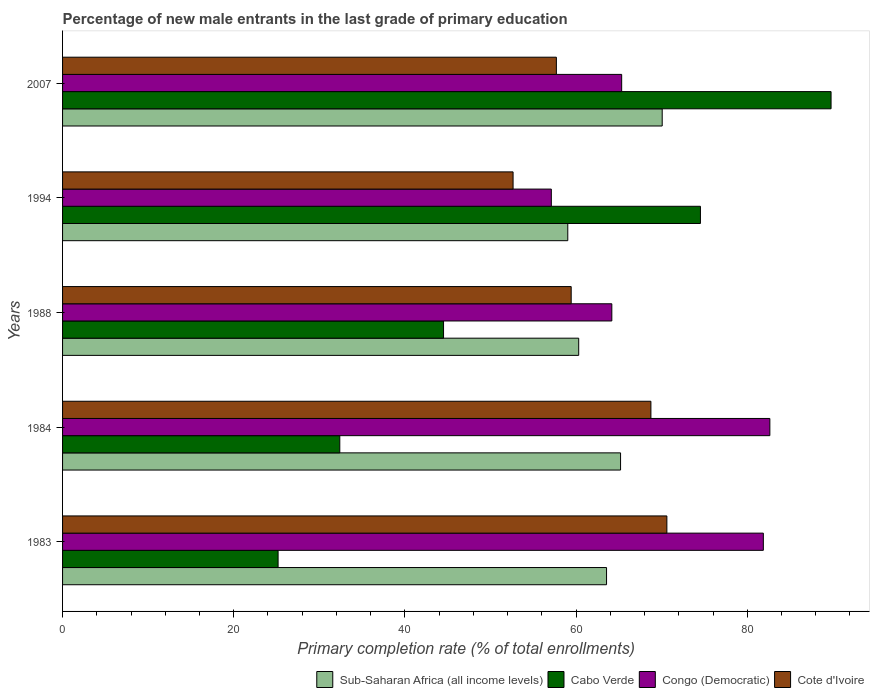How many different coloured bars are there?
Offer a terse response. 4. Are the number of bars on each tick of the Y-axis equal?
Ensure brevity in your answer.  Yes. How many bars are there on the 5th tick from the bottom?
Your response must be concise. 4. In how many cases, is the number of bars for a given year not equal to the number of legend labels?
Your answer should be compact. 0. What is the percentage of new male entrants in Cote d'Ivoire in 2007?
Make the answer very short. 57.7. Across all years, what is the maximum percentage of new male entrants in Sub-Saharan Africa (all income levels)?
Keep it short and to the point. 70.06. Across all years, what is the minimum percentage of new male entrants in Sub-Saharan Africa (all income levels)?
Provide a short and direct response. 59.03. In which year was the percentage of new male entrants in Congo (Democratic) maximum?
Ensure brevity in your answer.  1984. In which year was the percentage of new male entrants in Cote d'Ivoire minimum?
Give a very brief answer. 1994. What is the total percentage of new male entrants in Congo (Democratic) in the graph?
Offer a very short reply. 351.14. What is the difference between the percentage of new male entrants in Cabo Verde in 1988 and that in 2007?
Ensure brevity in your answer.  -45.28. What is the difference between the percentage of new male entrants in Sub-Saharan Africa (all income levels) in 1983 and the percentage of new male entrants in Cote d'Ivoire in 2007?
Your response must be concise. 5.86. What is the average percentage of new male entrants in Cote d'Ivoire per year?
Offer a terse response. 61.82. In the year 1994, what is the difference between the percentage of new male entrants in Cabo Verde and percentage of new male entrants in Sub-Saharan Africa (all income levels)?
Your answer should be compact. 15.5. In how many years, is the percentage of new male entrants in Cabo Verde greater than 24 %?
Offer a very short reply. 5. What is the ratio of the percentage of new male entrants in Sub-Saharan Africa (all income levels) in 1983 to that in 1994?
Your response must be concise. 1.08. What is the difference between the highest and the second highest percentage of new male entrants in Cote d'Ivoire?
Provide a succinct answer. 1.87. What is the difference between the highest and the lowest percentage of new male entrants in Sub-Saharan Africa (all income levels)?
Give a very brief answer. 11.03. Is it the case that in every year, the sum of the percentage of new male entrants in Sub-Saharan Africa (all income levels) and percentage of new male entrants in Cabo Verde is greater than the sum of percentage of new male entrants in Congo (Democratic) and percentage of new male entrants in Cote d'Ivoire?
Your answer should be compact. No. What does the 3rd bar from the top in 1984 represents?
Ensure brevity in your answer.  Cabo Verde. What does the 4th bar from the bottom in 1983 represents?
Provide a succinct answer. Cote d'Ivoire. Is it the case that in every year, the sum of the percentage of new male entrants in Cote d'Ivoire and percentage of new male entrants in Sub-Saharan Africa (all income levels) is greater than the percentage of new male entrants in Cabo Verde?
Provide a succinct answer. Yes. How many bars are there?
Provide a succinct answer. 20. Are all the bars in the graph horizontal?
Ensure brevity in your answer.  Yes. What is the difference between two consecutive major ticks on the X-axis?
Offer a terse response. 20. Are the values on the major ticks of X-axis written in scientific E-notation?
Your answer should be compact. No. Does the graph contain any zero values?
Your answer should be very brief. No. How are the legend labels stacked?
Your answer should be compact. Horizontal. What is the title of the graph?
Offer a very short reply. Percentage of new male entrants in the last grade of primary education. What is the label or title of the X-axis?
Provide a short and direct response. Primary completion rate (% of total enrollments). What is the Primary completion rate (% of total enrollments) in Sub-Saharan Africa (all income levels) in 1983?
Your answer should be very brief. 63.56. What is the Primary completion rate (% of total enrollments) in Cabo Verde in 1983?
Provide a short and direct response. 25.18. What is the Primary completion rate (% of total enrollments) of Congo (Democratic) in 1983?
Keep it short and to the point. 81.88. What is the Primary completion rate (% of total enrollments) of Cote d'Ivoire in 1983?
Keep it short and to the point. 70.61. What is the Primary completion rate (% of total enrollments) of Sub-Saharan Africa (all income levels) in 1984?
Keep it short and to the point. 65.2. What is the Primary completion rate (% of total enrollments) of Cabo Verde in 1984?
Ensure brevity in your answer.  32.39. What is the Primary completion rate (% of total enrollments) of Congo (Democratic) in 1984?
Ensure brevity in your answer.  82.64. What is the Primary completion rate (% of total enrollments) in Cote d'Ivoire in 1984?
Make the answer very short. 68.74. What is the Primary completion rate (% of total enrollments) of Sub-Saharan Africa (all income levels) in 1988?
Your response must be concise. 60.31. What is the Primary completion rate (% of total enrollments) of Cabo Verde in 1988?
Keep it short and to the point. 44.52. What is the Primary completion rate (% of total enrollments) in Congo (Democratic) in 1988?
Make the answer very short. 64.18. What is the Primary completion rate (% of total enrollments) in Cote d'Ivoire in 1988?
Your answer should be very brief. 59.43. What is the Primary completion rate (% of total enrollments) in Sub-Saharan Africa (all income levels) in 1994?
Your response must be concise. 59.03. What is the Primary completion rate (% of total enrollments) of Cabo Verde in 1994?
Provide a succinct answer. 74.53. What is the Primary completion rate (% of total enrollments) in Congo (Democratic) in 1994?
Make the answer very short. 57.11. What is the Primary completion rate (% of total enrollments) of Cote d'Ivoire in 1994?
Your answer should be very brief. 52.64. What is the Primary completion rate (% of total enrollments) of Sub-Saharan Africa (all income levels) in 2007?
Your answer should be compact. 70.06. What is the Primary completion rate (% of total enrollments) in Cabo Verde in 2007?
Provide a succinct answer. 89.8. What is the Primary completion rate (% of total enrollments) in Congo (Democratic) in 2007?
Make the answer very short. 65.33. What is the Primary completion rate (% of total enrollments) of Cote d'Ivoire in 2007?
Provide a short and direct response. 57.7. Across all years, what is the maximum Primary completion rate (% of total enrollments) of Sub-Saharan Africa (all income levels)?
Give a very brief answer. 70.06. Across all years, what is the maximum Primary completion rate (% of total enrollments) in Cabo Verde?
Your answer should be compact. 89.8. Across all years, what is the maximum Primary completion rate (% of total enrollments) of Congo (Democratic)?
Provide a short and direct response. 82.64. Across all years, what is the maximum Primary completion rate (% of total enrollments) of Cote d'Ivoire?
Ensure brevity in your answer.  70.61. Across all years, what is the minimum Primary completion rate (% of total enrollments) of Sub-Saharan Africa (all income levels)?
Ensure brevity in your answer.  59.03. Across all years, what is the minimum Primary completion rate (% of total enrollments) in Cabo Verde?
Keep it short and to the point. 25.18. Across all years, what is the minimum Primary completion rate (% of total enrollments) of Congo (Democratic)?
Your answer should be compact. 57.11. Across all years, what is the minimum Primary completion rate (% of total enrollments) in Cote d'Ivoire?
Your answer should be compact. 52.64. What is the total Primary completion rate (% of total enrollments) of Sub-Saharan Africa (all income levels) in the graph?
Offer a terse response. 318.17. What is the total Primary completion rate (% of total enrollments) in Cabo Verde in the graph?
Provide a short and direct response. 266.42. What is the total Primary completion rate (% of total enrollments) of Congo (Democratic) in the graph?
Make the answer very short. 351.14. What is the total Primary completion rate (% of total enrollments) of Cote d'Ivoire in the graph?
Your answer should be compact. 309.12. What is the difference between the Primary completion rate (% of total enrollments) of Sub-Saharan Africa (all income levels) in 1983 and that in 1984?
Provide a succinct answer. -1.64. What is the difference between the Primary completion rate (% of total enrollments) of Cabo Verde in 1983 and that in 1984?
Your answer should be very brief. -7.21. What is the difference between the Primary completion rate (% of total enrollments) in Congo (Democratic) in 1983 and that in 1984?
Provide a succinct answer. -0.76. What is the difference between the Primary completion rate (% of total enrollments) of Cote d'Ivoire in 1983 and that in 1984?
Give a very brief answer. 1.87. What is the difference between the Primary completion rate (% of total enrollments) of Sub-Saharan Africa (all income levels) in 1983 and that in 1988?
Provide a succinct answer. 3.25. What is the difference between the Primary completion rate (% of total enrollments) of Cabo Verde in 1983 and that in 1988?
Ensure brevity in your answer.  -19.33. What is the difference between the Primary completion rate (% of total enrollments) in Congo (Democratic) in 1983 and that in 1988?
Offer a very short reply. 17.7. What is the difference between the Primary completion rate (% of total enrollments) in Cote d'Ivoire in 1983 and that in 1988?
Your answer should be very brief. 11.18. What is the difference between the Primary completion rate (% of total enrollments) in Sub-Saharan Africa (all income levels) in 1983 and that in 1994?
Make the answer very short. 4.53. What is the difference between the Primary completion rate (% of total enrollments) in Cabo Verde in 1983 and that in 1994?
Your answer should be compact. -49.35. What is the difference between the Primary completion rate (% of total enrollments) of Congo (Democratic) in 1983 and that in 1994?
Your answer should be compact. 24.77. What is the difference between the Primary completion rate (% of total enrollments) in Cote d'Ivoire in 1983 and that in 1994?
Provide a short and direct response. 17.97. What is the difference between the Primary completion rate (% of total enrollments) in Sub-Saharan Africa (all income levels) in 1983 and that in 2007?
Offer a terse response. -6.5. What is the difference between the Primary completion rate (% of total enrollments) of Cabo Verde in 1983 and that in 2007?
Give a very brief answer. -64.61. What is the difference between the Primary completion rate (% of total enrollments) in Congo (Democratic) in 1983 and that in 2007?
Provide a short and direct response. 16.55. What is the difference between the Primary completion rate (% of total enrollments) of Cote d'Ivoire in 1983 and that in 2007?
Your answer should be compact. 12.91. What is the difference between the Primary completion rate (% of total enrollments) of Sub-Saharan Africa (all income levels) in 1984 and that in 1988?
Provide a short and direct response. 4.89. What is the difference between the Primary completion rate (% of total enrollments) of Cabo Verde in 1984 and that in 1988?
Make the answer very short. -12.12. What is the difference between the Primary completion rate (% of total enrollments) in Congo (Democratic) in 1984 and that in 1988?
Your response must be concise. 18.46. What is the difference between the Primary completion rate (% of total enrollments) in Cote d'Ivoire in 1984 and that in 1988?
Provide a succinct answer. 9.31. What is the difference between the Primary completion rate (% of total enrollments) in Sub-Saharan Africa (all income levels) in 1984 and that in 1994?
Your answer should be compact. 6.17. What is the difference between the Primary completion rate (% of total enrollments) in Cabo Verde in 1984 and that in 1994?
Make the answer very short. -42.14. What is the difference between the Primary completion rate (% of total enrollments) of Congo (Democratic) in 1984 and that in 1994?
Offer a very short reply. 25.53. What is the difference between the Primary completion rate (% of total enrollments) in Cote d'Ivoire in 1984 and that in 1994?
Your answer should be very brief. 16.1. What is the difference between the Primary completion rate (% of total enrollments) in Sub-Saharan Africa (all income levels) in 1984 and that in 2007?
Your answer should be very brief. -4.86. What is the difference between the Primary completion rate (% of total enrollments) in Cabo Verde in 1984 and that in 2007?
Offer a very short reply. -57.4. What is the difference between the Primary completion rate (% of total enrollments) of Congo (Democratic) in 1984 and that in 2007?
Give a very brief answer. 17.31. What is the difference between the Primary completion rate (% of total enrollments) of Cote d'Ivoire in 1984 and that in 2007?
Offer a very short reply. 11.05. What is the difference between the Primary completion rate (% of total enrollments) of Sub-Saharan Africa (all income levels) in 1988 and that in 1994?
Your answer should be compact. 1.28. What is the difference between the Primary completion rate (% of total enrollments) in Cabo Verde in 1988 and that in 1994?
Keep it short and to the point. -30.02. What is the difference between the Primary completion rate (% of total enrollments) of Congo (Democratic) in 1988 and that in 1994?
Your answer should be very brief. 7.07. What is the difference between the Primary completion rate (% of total enrollments) in Cote d'Ivoire in 1988 and that in 1994?
Your response must be concise. 6.79. What is the difference between the Primary completion rate (% of total enrollments) of Sub-Saharan Africa (all income levels) in 1988 and that in 2007?
Give a very brief answer. -9.76. What is the difference between the Primary completion rate (% of total enrollments) in Cabo Verde in 1988 and that in 2007?
Provide a short and direct response. -45.28. What is the difference between the Primary completion rate (% of total enrollments) in Congo (Democratic) in 1988 and that in 2007?
Make the answer very short. -1.15. What is the difference between the Primary completion rate (% of total enrollments) in Cote d'Ivoire in 1988 and that in 2007?
Offer a terse response. 1.73. What is the difference between the Primary completion rate (% of total enrollments) in Sub-Saharan Africa (all income levels) in 1994 and that in 2007?
Your answer should be very brief. -11.03. What is the difference between the Primary completion rate (% of total enrollments) in Cabo Verde in 1994 and that in 2007?
Make the answer very short. -15.26. What is the difference between the Primary completion rate (% of total enrollments) in Congo (Democratic) in 1994 and that in 2007?
Your response must be concise. -8.22. What is the difference between the Primary completion rate (% of total enrollments) of Cote d'Ivoire in 1994 and that in 2007?
Make the answer very short. -5.06. What is the difference between the Primary completion rate (% of total enrollments) of Sub-Saharan Africa (all income levels) in 1983 and the Primary completion rate (% of total enrollments) of Cabo Verde in 1984?
Offer a very short reply. 31.17. What is the difference between the Primary completion rate (% of total enrollments) of Sub-Saharan Africa (all income levels) in 1983 and the Primary completion rate (% of total enrollments) of Congo (Democratic) in 1984?
Ensure brevity in your answer.  -19.08. What is the difference between the Primary completion rate (% of total enrollments) in Sub-Saharan Africa (all income levels) in 1983 and the Primary completion rate (% of total enrollments) in Cote d'Ivoire in 1984?
Ensure brevity in your answer.  -5.18. What is the difference between the Primary completion rate (% of total enrollments) of Cabo Verde in 1983 and the Primary completion rate (% of total enrollments) of Congo (Democratic) in 1984?
Give a very brief answer. -57.46. What is the difference between the Primary completion rate (% of total enrollments) in Cabo Verde in 1983 and the Primary completion rate (% of total enrollments) in Cote d'Ivoire in 1984?
Your answer should be very brief. -43.56. What is the difference between the Primary completion rate (% of total enrollments) of Congo (Democratic) in 1983 and the Primary completion rate (% of total enrollments) of Cote d'Ivoire in 1984?
Ensure brevity in your answer.  13.14. What is the difference between the Primary completion rate (% of total enrollments) of Sub-Saharan Africa (all income levels) in 1983 and the Primary completion rate (% of total enrollments) of Cabo Verde in 1988?
Your answer should be very brief. 19.05. What is the difference between the Primary completion rate (% of total enrollments) in Sub-Saharan Africa (all income levels) in 1983 and the Primary completion rate (% of total enrollments) in Congo (Democratic) in 1988?
Give a very brief answer. -0.62. What is the difference between the Primary completion rate (% of total enrollments) of Sub-Saharan Africa (all income levels) in 1983 and the Primary completion rate (% of total enrollments) of Cote d'Ivoire in 1988?
Your answer should be very brief. 4.13. What is the difference between the Primary completion rate (% of total enrollments) in Cabo Verde in 1983 and the Primary completion rate (% of total enrollments) in Congo (Democratic) in 1988?
Provide a succinct answer. -39. What is the difference between the Primary completion rate (% of total enrollments) of Cabo Verde in 1983 and the Primary completion rate (% of total enrollments) of Cote d'Ivoire in 1988?
Your answer should be compact. -34.25. What is the difference between the Primary completion rate (% of total enrollments) of Congo (Democratic) in 1983 and the Primary completion rate (% of total enrollments) of Cote d'Ivoire in 1988?
Ensure brevity in your answer.  22.45. What is the difference between the Primary completion rate (% of total enrollments) in Sub-Saharan Africa (all income levels) in 1983 and the Primary completion rate (% of total enrollments) in Cabo Verde in 1994?
Provide a succinct answer. -10.97. What is the difference between the Primary completion rate (% of total enrollments) in Sub-Saharan Africa (all income levels) in 1983 and the Primary completion rate (% of total enrollments) in Congo (Democratic) in 1994?
Ensure brevity in your answer.  6.45. What is the difference between the Primary completion rate (% of total enrollments) of Sub-Saharan Africa (all income levels) in 1983 and the Primary completion rate (% of total enrollments) of Cote d'Ivoire in 1994?
Offer a terse response. 10.92. What is the difference between the Primary completion rate (% of total enrollments) in Cabo Verde in 1983 and the Primary completion rate (% of total enrollments) in Congo (Democratic) in 1994?
Provide a succinct answer. -31.93. What is the difference between the Primary completion rate (% of total enrollments) of Cabo Verde in 1983 and the Primary completion rate (% of total enrollments) of Cote d'Ivoire in 1994?
Give a very brief answer. -27.46. What is the difference between the Primary completion rate (% of total enrollments) of Congo (Democratic) in 1983 and the Primary completion rate (% of total enrollments) of Cote d'Ivoire in 1994?
Your response must be concise. 29.24. What is the difference between the Primary completion rate (% of total enrollments) in Sub-Saharan Africa (all income levels) in 1983 and the Primary completion rate (% of total enrollments) in Cabo Verde in 2007?
Your answer should be compact. -26.23. What is the difference between the Primary completion rate (% of total enrollments) of Sub-Saharan Africa (all income levels) in 1983 and the Primary completion rate (% of total enrollments) of Congo (Democratic) in 2007?
Provide a short and direct response. -1.77. What is the difference between the Primary completion rate (% of total enrollments) of Sub-Saharan Africa (all income levels) in 1983 and the Primary completion rate (% of total enrollments) of Cote d'Ivoire in 2007?
Make the answer very short. 5.86. What is the difference between the Primary completion rate (% of total enrollments) in Cabo Verde in 1983 and the Primary completion rate (% of total enrollments) in Congo (Democratic) in 2007?
Give a very brief answer. -40.15. What is the difference between the Primary completion rate (% of total enrollments) in Cabo Verde in 1983 and the Primary completion rate (% of total enrollments) in Cote d'Ivoire in 2007?
Ensure brevity in your answer.  -32.52. What is the difference between the Primary completion rate (% of total enrollments) in Congo (Democratic) in 1983 and the Primary completion rate (% of total enrollments) in Cote d'Ivoire in 2007?
Your answer should be compact. 24.18. What is the difference between the Primary completion rate (% of total enrollments) in Sub-Saharan Africa (all income levels) in 1984 and the Primary completion rate (% of total enrollments) in Cabo Verde in 1988?
Your answer should be compact. 20.68. What is the difference between the Primary completion rate (% of total enrollments) of Sub-Saharan Africa (all income levels) in 1984 and the Primary completion rate (% of total enrollments) of Congo (Democratic) in 1988?
Keep it short and to the point. 1.02. What is the difference between the Primary completion rate (% of total enrollments) of Sub-Saharan Africa (all income levels) in 1984 and the Primary completion rate (% of total enrollments) of Cote d'Ivoire in 1988?
Your response must be concise. 5.77. What is the difference between the Primary completion rate (% of total enrollments) in Cabo Verde in 1984 and the Primary completion rate (% of total enrollments) in Congo (Democratic) in 1988?
Make the answer very short. -31.79. What is the difference between the Primary completion rate (% of total enrollments) in Cabo Verde in 1984 and the Primary completion rate (% of total enrollments) in Cote d'Ivoire in 1988?
Give a very brief answer. -27.04. What is the difference between the Primary completion rate (% of total enrollments) in Congo (Democratic) in 1984 and the Primary completion rate (% of total enrollments) in Cote d'Ivoire in 1988?
Your answer should be very brief. 23.21. What is the difference between the Primary completion rate (% of total enrollments) of Sub-Saharan Africa (all income levels) in 1984 and the Primary completion rate (% of total enrollments) of Cabo Verde in 1994?
Provide a short and direct response. -9.33. What is the difference between the Primary completion rate (% of total enrollments) in Sub-Saharan Africa (all income levels) in 1984 and the Primary completion rate (% of total enrollments) in Congo (Democratic) in 1994?
Your response must be concise. 8.09. What is the difference between the Primary completion rate (% of total enrollments) in Sub-Saharan Africa (all income levels) in 1984 and the Primary completion rate (% of total enrollments) in Cote d'Ivoire in 1994?
Offer a very short reply. 12.56. What is the difference between the Primary completion rate (% of total enrollments) of Cabo Verde in 1984 and the Primary completion rate (% of total enrollments) of Congo (Democratic) in 1994?
Provide a succinct answer. -24.72. What is the difference between the Primary completion rate (% of total enrollments) of Cabo Verde in 1984 and the Primary completion rate (% of total enrollments) of Cote d'Ivoire in 1994?
Offer a terse response. -20.25. What is the difference between the Primary completion rate (% of total enrollments) of Congo (Democratic) in 1984 and the Primary completion rate (% of total enrollments) of Cote d'Ivoire in 1994?
Your answer should be compact. 30. What is the difference between the Primary completion rate (% of total enrollments) of Sub-Saharan Africa (all income levels) in 1984 and the Primary completion rate (% of total enrollments) of Cabo Verde in 2007?
Ensure brevity in your answer.  -24.6. What is the difference between the Primary completion rate (% of total enrollments) of Sub-Saharan Africa (all income levels) in 1984 and the Primary completion rate (% of total enrollments) of Congo (Democratic) in 2007?
Give a very brief answer. -0.13. What is the difference between the Primary completion rate (% of total enrollments) of Sub-Saharan Africa (all income levels) in 1984 and the Primary completion rate (% of total enrollments) of Cote d'Ivoire in 2007?
Give a very brief answer. 7.5. What is the difference between the Primary completion rate (% of total enrollments) in Cabo Verde in 1984 and the Primary completion rate (% of total enrollments) in Congo (Democratic) in 2007?
Offer a very short reply. -32.94. What is the difference between the Primary completion rate (% of total enrollments) of Cabo Verde in 1984 and the Primary completion rate (% of total enrollments) of Cote d'Ivoire in 2007?
Offer a very short reply. -25.31. What is the difference between the Primary completion rate (% of total enrollments) of Congo (Democratic) in 1984 and the Primary completion rate (% of total enrollments) of Cote d'Ivoire in 2007?
Offer a very short reply. 24.94. What is the difference between the Primary completion rate (% of total enrollments) in Sub-Saharan Africa (all income levels) in 1988 and the Primary completion rate (% of total enrollments) in Cabo Verde in 1994?
Your answer should be very brief. -14.22. What is the difference between the Primary completion rate (% of total enrollments) in Sub-Saharan Africa (all income levels) in 1988 and the Primary completion rate (% of total enrollments) in Congo (Democratic) in 1994?
Your answer should be compact. 3.2. What is the difference between the Primary completion rate (% of total enrollments) in Sub-Saharan Africa (all income levels) in 1988 and the Primary completion rate (% of total enrollments) in Cote d'Ivoire in 1994?
Make the answer very short. 7.67. What is the difference between the Primary completion rate (% of total enrollments) of Cabo Verde in 1988 and the Primary completion rate (% of total enrollments) of Congo (Democratic) in 1994?
Make the answer very short. -12.59. What is the difference between the Primary completion rate (% of total enrollments) of Cabo Verde in 1988 and the Primary completion rate (% of total enrollments) of Cote d'Ivoire in 1994?
Provide a short and direct response. -8.12. What is the difference between the Primary completion rate (% of total enrollments) of Congo (Democratic) in 1988 and the Primary completion rate (% of total enrollments) of Cote d'Ivoire in 1994?
Give a very brief answer. 11.54. What is the difference between the Primary completion rate (% of total enrollments) in Sub-Saharan Africa (all income levels) in 1988 and the Primary completion rate (% of total enrollments) in Cabo Verde in 2007?
Offer a very short reply. -29.49. What is the difference between the Primary completion rate (% of total enrollments) in Sub-Saharan Africa (all income levels) in 1988 and the Primary completion rate (% of total enrollments) in Congo (Democratic) in 2007?
Make the answer very short. -5.02. What is the difference between the Primary completion rate (% of total enrollments) in Sub-Saharan Africa (all income levels) in 1988 and the Primary completion rate (% of total enrollments) in Cote d'Ivoire in 2007?
Keep it short and to the point. 2.61. What is the difference between the Primary completion rate (% of total enrollments) in Cabo Verde in 1988 and the Primary completion rate (% of total enrollments) in Congo (Democratic) in 2007?
Your answer should be very brief. -20.81. What is the difference between the Primary completion rate (% of total enrollments) of Cabo Verde in 1988 and the Primary completion rate (% of total enrollments) of Cote d'Ivoire in 2007?
Your answer should be compact. -13.18. What is the difference between the Primary completion rate (% of total enrollments) of Congo (Democratic) in 1988 and the Primary completion rate (% of total enrollments) of Cote d'Ivoire in 2007?
Your answer should be compact. 6.48. What is the difference between the Primary completion rate (% of total enrollments) in Sub-Saharan Africa (all income levels) in 1994 and the Primary completion rate (% of total enrollments) in Cabo Verde in 2007?
Make the answer very short. -30.76. What is the difference between the Primary completion rate (% of total enrollments) in Sub-Saharan Africa (all income levels) in 1994 and the Primary completion rate (% of total enrollments) in Congo (Democratic) in 2007?
Your answer should be compact. -6.3. What is the difference between the Primary completion rate (% of total enrollments) of Sub-Saharan Africa (all income levels) in 1994 and the Primary completion rate (% of total enrollments) of Cote d'Ivoire in 2007?
Provide a succinct answer. 1.33. What is the difference between the Primary completion rate (% of total enrollments) of Cabo Verde in 1994 and the Primary completion rate (% of total enrollments) of Congo (Democratic) in 2007?
Offer a very short reply. 9.2. What is the difference between the Primary completion rate (% of total enrollments) of Cabo Verde in 1994 and the Primary completion rate (% of total enrollments) of Cote d'Ivoire in 2007?
Offer a very short reply. 16.83. What is the difference between the Primary completion rate (% of total enrollments) in Congo (Democratic) in 1994 and the Primary completion rate (% of total enrollments) in Cote d'Ivoire in 2007?
Offer a terse response. -0.59. What is the average Primary completion rate (% of total enrollments) in Sub-Saharan Africa (all income levels) per year?
Provide a succinct answer. 63.63. What is the average Primary completion rate (% of total enrollments) in Cabo Verde per year?
Keep it short and to the point. 53.28. What is the average Primary completion rate (% of total enrollments) of Congo (Democratic) per year?
Your answer should be compact. 70.23. What is the average Primary completion rate (% of total enrollments) in Cote d'Ivoire per year?
Offer a very short reply. 61.83. In the year 1983, what is the difference between the Primary completion rate (% of total enrollments) of Sub-Saharan Africa (all income levels) and Primary completion rate (% of total enrollments) of Cabo Verde?
Your response must be concise. 38.38. In the year 1983, what is the difference between the Primary completion rate (% of total enrollments) of Sub-Saharan Africa (all income levels) and Primary completion rate (% of total enrollments) of Congo (Democratic)?
Offer a very short reply. -18.32. In the year 1983, what is the difference between the Primary completion rate (% of total enrollments) of Sub-Saharan Africa (all income levels) and Primary completion rate (% of total enrollments) of Cote d'Ivoire?
Your answer should be compact. -7.05. In the year 1983, what is the difference between the Primary completion rate (% of total enrollments) in Cabo Verde and Primary completion rate (% of total enrollments) in Congo (Democratic)?
Offer a terse response. -56.7. In the year 1983, what is the difference between the Primary completion rate (% of total enrollments) of Cabo Verde and Primary completion rate (% of total enrollments) of Cote d'Ivoire?
Keep it short and to the point. -45.43. In the year 1983, what is the difference between the Primary completion rate (% of total enrollments) of Congo (Democratic) and Primary completion rate (% of total enrollments) of Cote d'Ivoire?
Offer a very short reply. 11.27. In the year 1984, what is the difference between the Primary completion rate (% of total enrollments) in Sub-Saharan Africa (all income levels) and Primary completion rate (% of total enrollments) in Cabo Verde?
Ensure brevity in your answer.  32.81. In the year 1984, what is the difference between the Primary completion rate (% of total enrollments) in Sub-Saharan Africa (all income levels) and Primary completion rate (% of total enrollments) in Congo (Democratic)?
Offer a very short reply. -17.44. In the year 1984, what is the difference between the Primary completion rate (% of total enrollments) in Sub-Saharan Africa (all income levels) and Primary completion rate (% of total enrollments) in Cote d'Ivoire?
Offer a terse response. -3.54. In the year 1984, what is the difference between the Primary completion rate (% of total enrollments) of Cabo Verde and Primary completion rate (% of total enrollments) of Congo (Democratic)?
Your response must be concise. -50.25. In the year 1984, what is the difference between the Primary completion rate (% of total enrollments) of Cabo Verde and Primary completion rate (% of total enrollments) of Cote d'Ivoire?
Your response must be concise. -36.35. In the year 1984, what is the difference between the Primary completion rate (% of total enrollments) of Congo (Democratic) and Primary completion rate (% of total enrollments) of Cote d'Ivoire?
Keep it short and to the point. 13.9. In the year 1988, what is the difference between the Primary completion rate (% of total enrollments) of Sub-Saharan Africa (all income levels) and Primary completion rate (% of total enrollments) of Cabo Verde?
Keep it short and to the point. 15.79. In the year 1988, what is the difference between the Primary completion rate (% of total enrollments) of Sub-Saharan Africa (all income levels) and Primary completion rate (% of total enrollments) of Congo (Democratic)?
Your answer should be very brief. -3.87. In the year 1988, what is the difference between the Primary completion rate (% of total enrollments) of Sub-Saharan Africa (all income levels) and Primary completion rate (% of total enrollments) of Cote d'Ivoire?
Provide a short and direct response. 0.88. In the year 1988, what is the difference between the Primary completion rate (% of total enrollments) of Cabo Verde and Primary completion rate (% of total enrollments) of Congo (Democratic)?
Offer a very short reply. -19.66. In the year 1988, what is the difference between the Primary completion rate (% of total enrollments) of Cabo Verde and Primary completion rate (% of total enrollments) of Cote d'Ivoire?
Make the answer very short. -14.91. In the year 1988, what is the difference between the Primary completion rate (% of total enrollments) of Congo (Democratic) and Primary completion rate (% of total enrollments) of Cote d'Ivoire?
Provide a succinct answer. 4.75. In the year 1994, what is the difference between the Primary completion rate (% of total enrollments) of Sub-Saharan Africa (all income levels) and Primary completion rate (% of total enrollments) of Cabo Verde?
Give a very brief answer. -15.5. In the year 1994, what is the difference between the Primary completion rate (% of total enrollments) in Sub-Saharan Africa (all income levels) and Primary completion rate (% of total enrollments) in Congo (Democratic)?
Ensure brevity in your answer.  1.92. In the year 1994, what is the difference between the Primary completion rate (% of total enrollments) in Sub-Saharan Africa (all income levels) and Primary completion rate (% of total enrollments) in Cote d'Ivoire?
Your answer should be very brief. 6.39. In the year 1994, what is the difference between the Primary completion rate (% of total enrollments) in Cabo Verde and Primary completion rate (% of total enrollments) in Congo (Democratic)?
Offer a terse response. 17.42. In the year 1994, what is the difference between the Primary completion rate (% of total enrollments) in Cabo Verde and Primary completion rate (% of total enrollments) in Cote d'Ivoire?
Your answer should be compact. 21.89. In the year 1994, what is the difference between the Primary completion rate (% of total enrollments) in Congo (Democratic) and Primary completion rate (% of total enrollments) in Cote d'Ivoire?
Keep it short and to the point. 4.47. In the year 2007, what is the difference between the Primary completion rate (% of total enrollments) in Sub-Saharan Africa (all income levels) and Primary completion rate (% of total enrollments) in Cabo Verde?
Offer a terse response. -19.73. In the year 2007, what is the difference between the Primary completion rate (% of total enrollments) of Sub-Saharan Africa (all income levels) and Primary completion rate (% of total enrollments) of Congo (Democratic)?
Ensure brevity in your answer.  4.73. In the year 2007, what is the difference between the Primary completion rate (% of total enrollments) in Sub-Saharan Africa (all income levels) and Primary completion rate (% of total enrollments) in Cote d'Ivoire?
Ensure brevity in your answer.  12.37. In the year 2007, what is the difference between the Primary completion rate (% of total enrollments) in Cabo Verde and Primary completion rate (% of total enrollments) in Congo (Democratic)?
Keep it short and to the point. 24.47. In the year 2007, what is the difference between the Primary completion rate (% of total enrollments) in Cabo Verde and Primary completion rate (% of total enrollments) in Cote d'Ivoire?
Provide a short and direct response. 32.1. In the year 2007, what is the difference between the Primary completion rate (% of total enrollments) in Congo (Democratic) and Primary completion rate (% of total enrollments) in Cote d'Ivoire?
Your answer should be compact. 7.63. What is the ratio of the Primary completion rate (% of total enrollments) in Sub-Saharan Africa (all income levels) in 1983 to that in 1984?
Make the answer very short. 0.97. What is the ratio of the Primary completion rate (% of total enrollments) of Cabo Verde in 1983 to that in 1984?
Your answer should be very brief. 0.78. What is the ratio of the Primary completion rate (% of total enrollments) of Congo (Democratic) in 1983 to that in 1984?
Offer a very short reply. 0.99. What is the ratio of the Primary completion rate (% of total enrollments) in Cote d'Ivoire in 1983 to that in 1984?
Give a very brief answer. 1.03. What is the ratio of the Primary completion rate (% of total enrollments) of Sub-Saharan Africa (all income levels) in 1983 to that in 1988?
Ensure brevity in your answer.  1.05. What is the ratio of the Primary completion rate (% of total enrollments) in Cabo Verde in 1983 to that in 1988?
Keep it short and to the point. 0.57. What is the ratio of the Primary completion rate (% of total enrollments) in Congo (Democratic) in 1983 to that in 1988?
Keep it short and to the point. 1.28. What is the ratio of the Primary completion rate (% of total enrollments) in Cote d'Ivoire in 1983 to that in 1988?
Provide a short and direct response. 1.19. What is the ratio of the Primary completion rate (% of total enrollments) of Sub-Saharan Africa (all income levels) in 1983 to that in 1994?
Provide a short and direct response. 1.08. What is the ratio of the Primary completion rate (% of total enrollments) in Cabo Verde in 1983 to that in 1994?
Keep it short and to the point. 0.34. What is the ratio of the Primary completion rate (% of total enrollments) in Congo (Democratic) in 1983 to that in 1994?
Give a very brief answer. 1.43. What is the ratio of the Primary completion rate (% of total enrollments) of Cote d'Ivoire in 1983 to that in 1994?
Provide a succinct answer. 1.34. What is the ratio of the Primary completion rate (% of total enrollments) of Sub-Saharan Africa (all income levels) in 1983 to that in 2007?
Give a very brief answer. 0.91. What is the ratio of the Primary completion rate (% of total enrollments) in Cabo Verde in 1983 to that in 2007?
Your answer should be very brief. 0.28. What is the ratio of the Primary completion rate (% of total enrollments) in Congo (Democratic) in 1983 to that in 2007?
Provide a succinct answer. 1.25. What is the ratio of the Primary completion rate (% of total enrollments) of Cote d'Ivoire in 1983 to that in 2007?
Offer a very short reply. 1.22. What is the ratio of the Primary completion rate (% of total enrollments) in Sub-Saharan Africa (all income levels) in 1984 to that in 1988?
Make the answer very short. 1.08. What is the ratio of the Primary completion rate (% of total enrollments) in Cabo Verde in 1984 to that in 1988?
Offer a very short reply. 0.73. What is the ratio of the Primary completion rate (% of total enrollments) in Congo (Democratic) in 1984 to that in 1988?
Your answer should be very brief. 1.29. What is the ratio of the Primary completion rate (% of total enrollments) in Cote d'Ivoire in 1984 to that in 1988?
Provide a succinct answer. 1.16. What is the ratio of the Primary completion rate (% of total enrollments) of Sub-Saharan Africa (all income levels) in 1984 to that in 1994?
Ensure brevity in your answer.  1.1. What is the ratio of the Primary completion rate (% of total enrollments) in Cabo Verde in 1984 to that in 1994?
Keep it short and to the point. 0.43. What is the ratio of the Primary completion rate (% of total enrollments) of Congo (Democratic) in 1984 to that in 1994?
Provide a short and direct response. 1.45. What is the ratio of the Primary completion rate (% of total enrollments) of Cote d'Ivoire in 1984 to that in 1994?
Your response must be concise. 1.31. What is the ratio of the Primary completion rate (% of total enrollments) of Sub-Saharan Africa (all income levels) in 1984 to that in 2007?
Your answer should be compact. 0.93. What is the ratio of the Primary completion rate (% of total enrollments) of Cabo Verde in 1984 to that in 2007?
Offer a very short reply. 0.36. What is the ratio of the Primary completion rate (% of total enrollments) in Congo (Democratic) in 1984 to that in 2007?
Keep it short and to the point. 1.26. What is the ratio of the Primary completion rate (% of total enrollments) in Cote d'Ivoire in 1984 to that in 2007?
Make the answer very short. 1.19. What is the ratio of the Primary completion rate (% of total enrollments) of Sub-Saharan Africa (all income levels) in 1988 to that in 1994?
Your answer should be compact. 1.02. What is the ratio of the Primary completion rate (% of total enrollments) in Cabo Verde in 1988 to that in 1994?
Make the answer very short. 0.6. What is the ratio of the Primary completion rate (% of total enrollments) of Congo (Democratic) in 1988 to that in 1994?
Provide a succinct answer. 1.12. What is the ratio of the Primary completion rate (% of total enrollments) in Cote d'Ivoire in 1988 to that in 1994?
Offer a very short reply. 1.13. What is the ratio of the Primary completion rate (% of total enrollments) of Sub-Saharan Africa (all income levels) in 1988 to that in 2007?
Make the answer very short. 0.86. What is the ratio of the Primary completion rate (% of total enrollments) of Cabo Verde in 1988 to that in 2007?
Ensure brevity in your answer.  0.5. What is the ratio of the Primary completion rate (% of total enrollments) of Congo (Democratic) in 1988 to that in 2007?
Ensure brevity in your answer.  0.98. What is the ratio of the Primary completion rate (% of total enrollments) in Cote d'Ivoire in 1988 to that in 2007?
Offer a very short reply. 1.03. What is the ratio of the Primary completion rate (% of total enrollments) in Sub-Saharan Africa (all income levels) in 1994 to that in 2007?
Keep it short and to the point. 0.84. What is the ratio of the Primary completion rate (% of total enrollments) in Cabo Verde in 1994 to that in 2007?
Offer a terse response. 0.83. What is the ratio of the Primary completion rate (% of total enrollments) of Congo (Democratic) in 1994 to that in 2007?
Give a very brief answer. 0.87. What is the ratio of the Primary completion rate (% of total enrollments) in Cote d'Ivoire in 1994 to that in 2007?
Ensure brevity in your answer.  0.91. What is the difference between the highest and the second highest Primary completion rate (% of total enrollments) in Sub-Saharan Africa (all income levels)?
Make the answer very short. 4.86. What is the difference between the highest and the second highest Primary completion rate (% of total enrollments) in Cabo Verde?
Offer a very short reply. 15.26. What is the difference between the highest and the second highest Primary completion rate (% of total enrollments) of Congo (Democratic)?
Ensure brevity in your answer.  0.76. What is the difference between the highest and the second highest Primary completion rate (% of total enrollments) of Cote d'Ivoire?
Keep it short and to the point. 1.87. What is the difference between the highest and the lowest Primary completion rate (% of total enrollments) in Sub-Saharan Africa (all income levels)?
Provide a short and direct response. 11.03. What is the difference between the highest and the lowest Primary completion rate (% of total enrollments) in Cabo Verde?
Give a very brief answer. 64.61. What is the difference between the highest and the lowest Primary completion rate (% of total enrollments) of Congo (Democratic)?
Offer a very short reply. 25.53. What is the difference between the highest and the lowest Primary completion rate (% of total enrollments) of Cote d'Ivoire?
Make the answer very short. 17.97. 